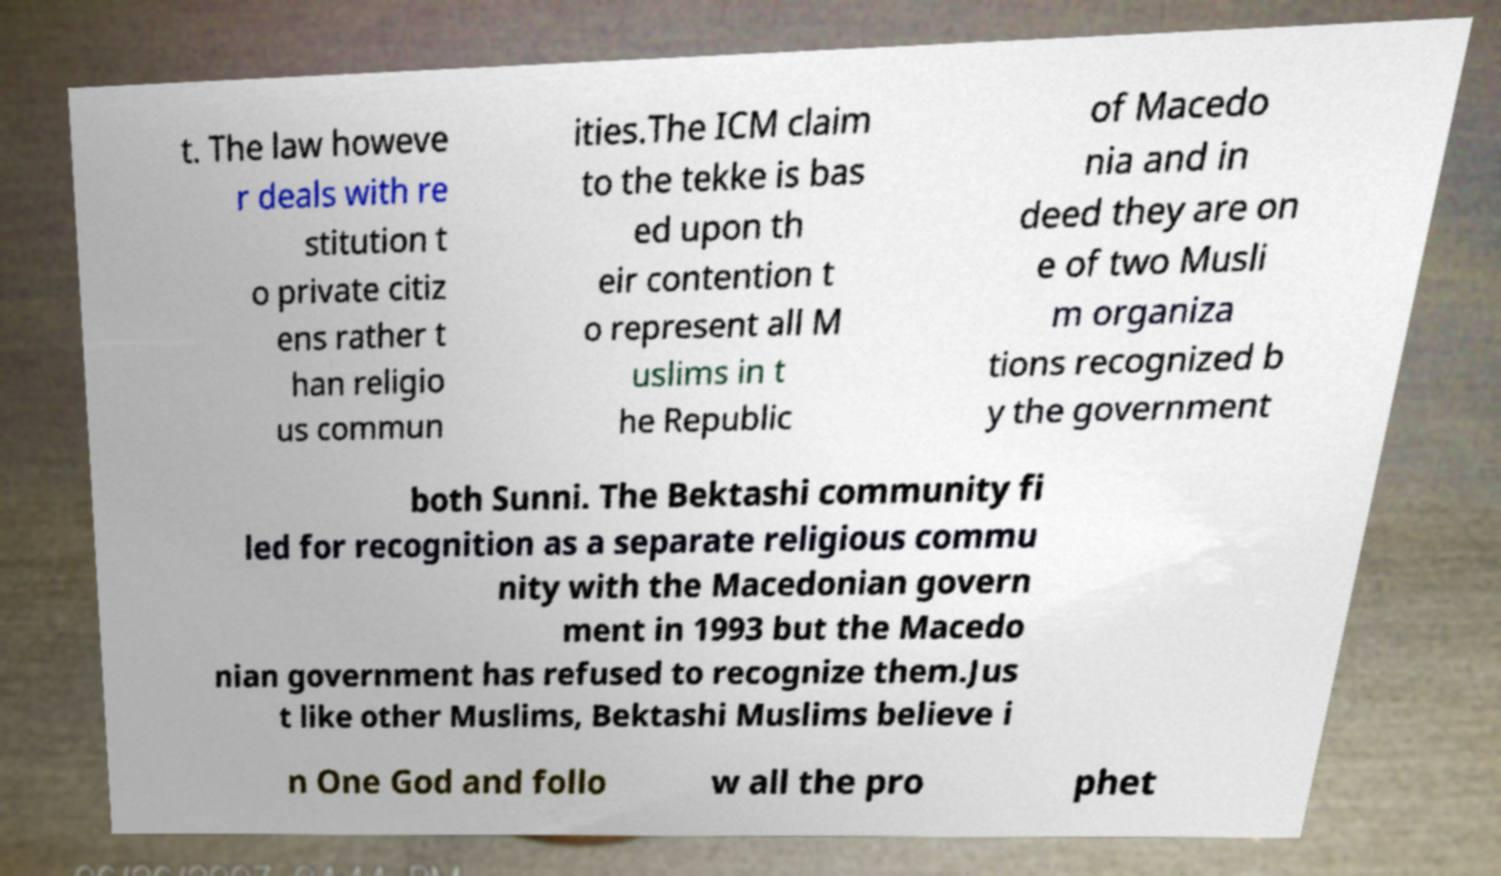Could you extract and type out the text from this image? t. The law howeve r deals with re stitution t o private citiz ens rather t han religio us commun ities.The ICM claim to the tekke is bas ed upon th eir contention t o represent all M uslims in t he Republic of Macedo nia and in deed they are on e of two Musli m organiza tions recognized b y the government both Sunni. The Bektashi community fi led for recognition as a separate religious commu nity with the Macedonian govern ment in 1993 but the Macedo nian government has refused to recognize them.Jus t like other Muslims, Bektashi Muslims believe i n One God and follo w all the pro phet 